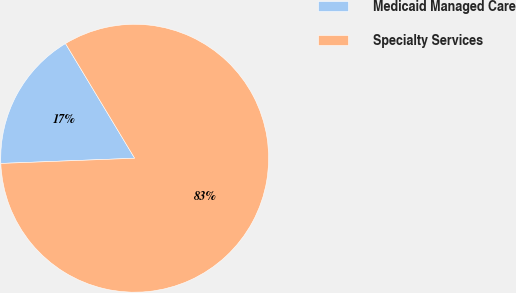Convert chart to OTSL. <chart><loc_0><loc_0><loc_500><loc_500><pie_chart><fcel>Medicaid Managed Care<fcel>Specialty Services<nl><fcel>16.98%<fcel>83.02%<nl></chart> 